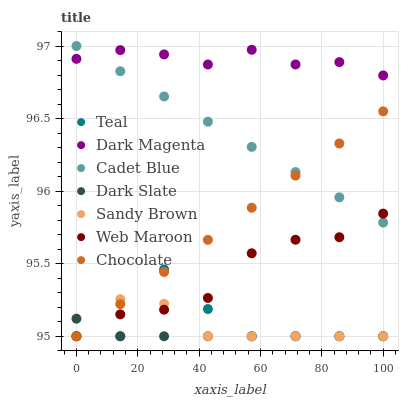Does Dark Slate have the minimum area under the curve?
Answer yes or no. Yes. Does Dark Magenta have the maximum area under the curve?
Answer yes or no. Yes. Does Web Maroon have the minimum area under the curve?
Answer yes or no. No. Does Web Maroon have the maximum area under the curve?
Answer yes or no. No. Is Cadet Blue the smoothest?
Answer yes or no. Yes. Is Teal the roughest?
Answer yes or no. Yes. Is Dark Magenta the smoothest?
Answer yes or no. No. Is Dark Magenta the roughest?
Answer yes or no. No. Does Web Maroon have the lowest value?
Answer yes or no. Yes. Does Dark Magenta have the lowest value?
Answer yes or no. No. Does Cadet Blue have the highest value?
Answer yes or no. Yes. Does Dark Magenta have the highest value?
Answer yes or no. No. Is Web Maroon less than Dark Magenta?
Answer yes or no. Yes. Is Dark Magenta greater than Teal?
Answer yes or no. Yes. Does Chocolate intersect Teal?
Answer yes or no. Yes. Is Chocolate less than Teal?
Answer yes or no. No. Is Chocolate greater than Teal?
Answer yes or no. No. Does Web Maroon intersect Dark Magenta?
Answer yes or no. No. 